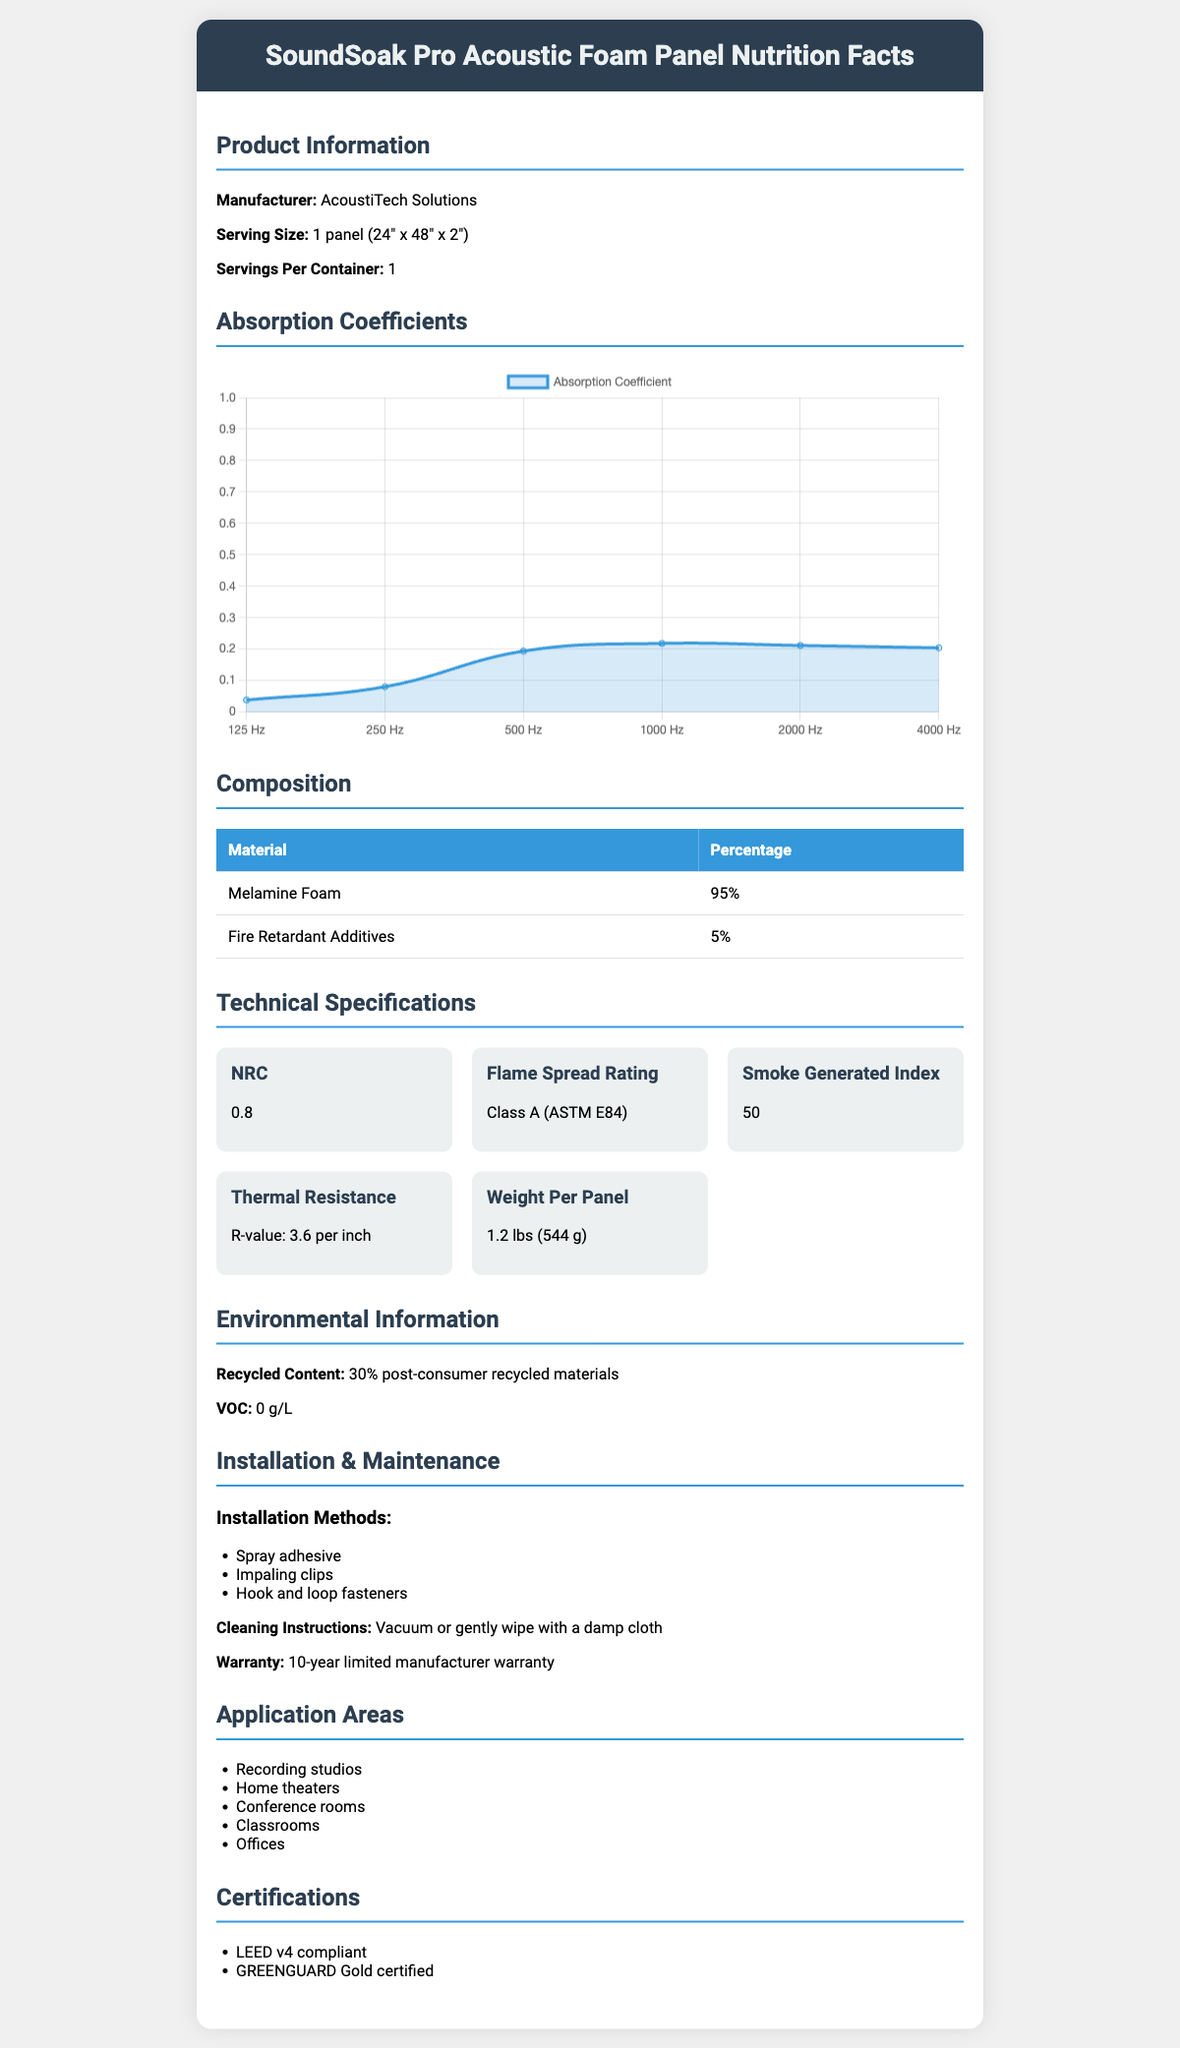What is the name of the product? The product name is clearly listed at the top of the document.
Answer: SoundSoak Pro Acoustic Foam Panel Who is the manufacturer of the SoundSoak Pro Acoustic Foam Panel? The manufacturer's name is stated under the Product Information section.
Answer: AcoustiTech Solutions What is the Noise Reduction Coefficient (NRC) of the panel? The NRC value is listed under the Technical Specifications section of the document.
Answer: 0.80 What frequency has the highest absorption coefficient? According to the Absorption Coefficients section, 1000 Hz has the highest coefficient of 0.98.
Answer: 1000 Hz How much of the panel composition is made up of Melamine Foam? The Composition section shows that 95% of the panel is made of Melamine Foam.
Answer: 95% What is the flame spread rating of the acoustic foam panel? A. Class A B. Class B C. Class C The flame spread rating is listed as Class A (ASTM E84) in the Technical Specifications section.
Answer: A. Class A Which frequency has the lowest absorption coefficient? A. 125 Hz B. 500 Hz C. 2000 Hz D. 1000 Hz From the Absorption Coefficients section, 125 Hz has the lowest value at 0.17.
Answer: A. 125 Hz Is the foam panel suitable for use in home theaters? Yes/No The Application Areas section lists home theaters as one of the suitable areas for the panel.
Answer: Yes Summarize the main ideas presented in the document. The document outlines various aspects of the product, such as its performance in terms of absorption coefficients at different frequencies, materials used, technical and environmental specifications, and areas where it can be applied.
Answer: The document provides detailed information about the SoundSoak Pro Acoustic Foam Panel, including product details, absorption coefficients, composition, technical specifications, environmental information, installation methods, application areas, and certifications. What is the total weight per container of the panels? The document mentions the weight per panel, but not the total weight per container explicitly.
Answer: Cannot be determined How is the panel primarily recommended to be cleaned? The Cleaning Instructions section states that the panels can be vacuumed or gently wiped with a damp cloth for maintenance.
Answer: Vacuum or gently wipe with a damp cloth What is the thermal resistance (R-value) of the panel? The R-value of the panel is listed as 3.6 per inch in the Technical Specifications section.
Answer: 3.6 per inch What are two certifications achieved by the product? The Certifications section lists these two certifications clearly.
Answer: LEED v4 compliant, GREENGUARD Gold certified What are the methods recommended for installing the panel? A. Adhesive, Nails, Screws B. Hook and Loop Fasteners, Spray Adhesive, Impaling Clips C. Tapes, Hooks, Glue D. Clips, Nails, Hooks The Installation Methods section specifies these three methods as recommended for installation.
Answer: B. Hook and Loop Fasteners, Spray Adhesive, Impaling Clips What percentage of post-consumer recycled materials does the panel contain? The Environmental Information section notes that the panel is made up of 30% post-consumer recycled materials.
Answer: 30% What does the document say about the VOC content of the panel? The VOC content is noted as 0 g/L in the Environmental Information section.
Answer: 0 g/L 